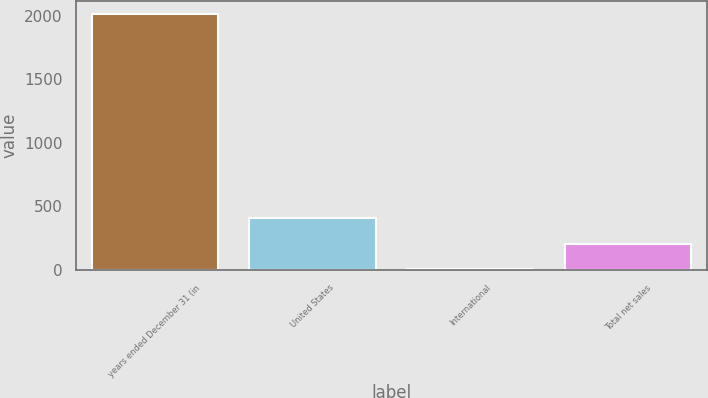<chart> <loc_0><loc_0><loc_500><loc_500><bar_chart><fcel>years ended December 31 (in<fcel>United States<fcel>International<fcel>Total net sales<nl><fcel>2012<fcel>405.6<fcel>4<fcel>204.8<nl></chart> 